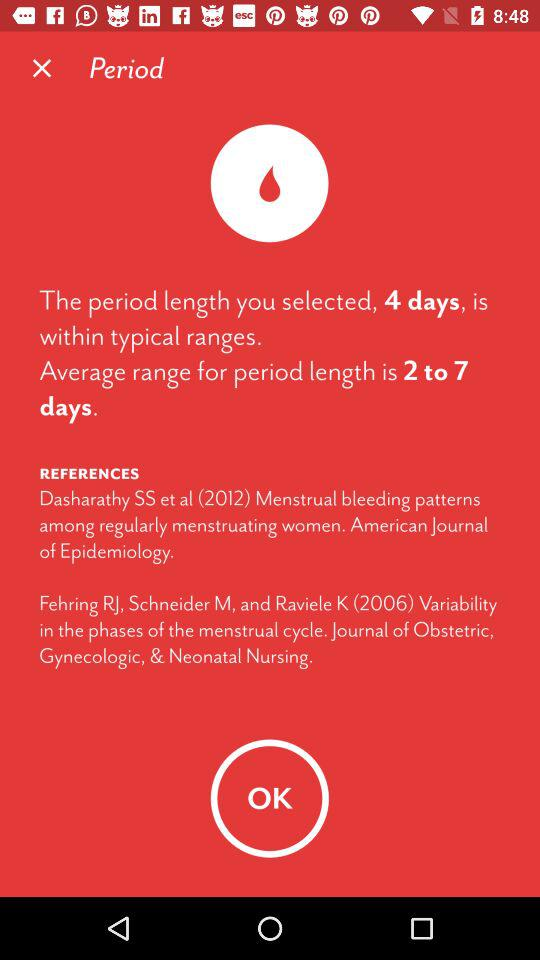What is the username?
When the provided information is insufficient, respond with <no answer>. <no answer> 